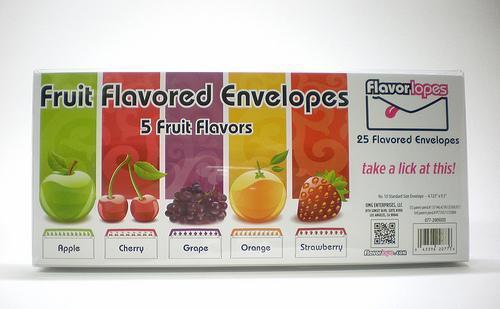How many different fruits are pictured?
Give a very brief answer. 5. 